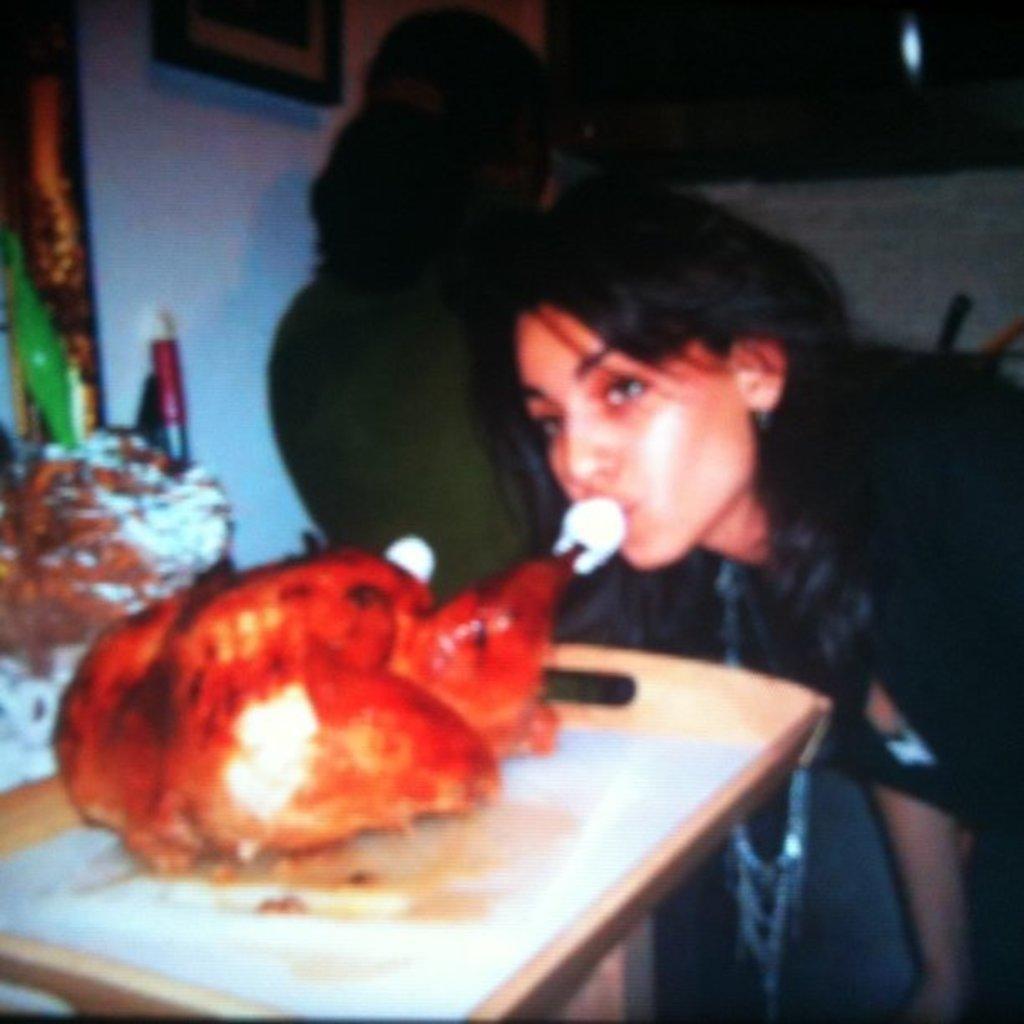Please provide a concise description of this image. In the center of the image we can see two ladies. At the bottom there is a table and we can see a tray, meat and some things placed on the table. In the background there is a wall and we can see a wall frame placed on the wall. 